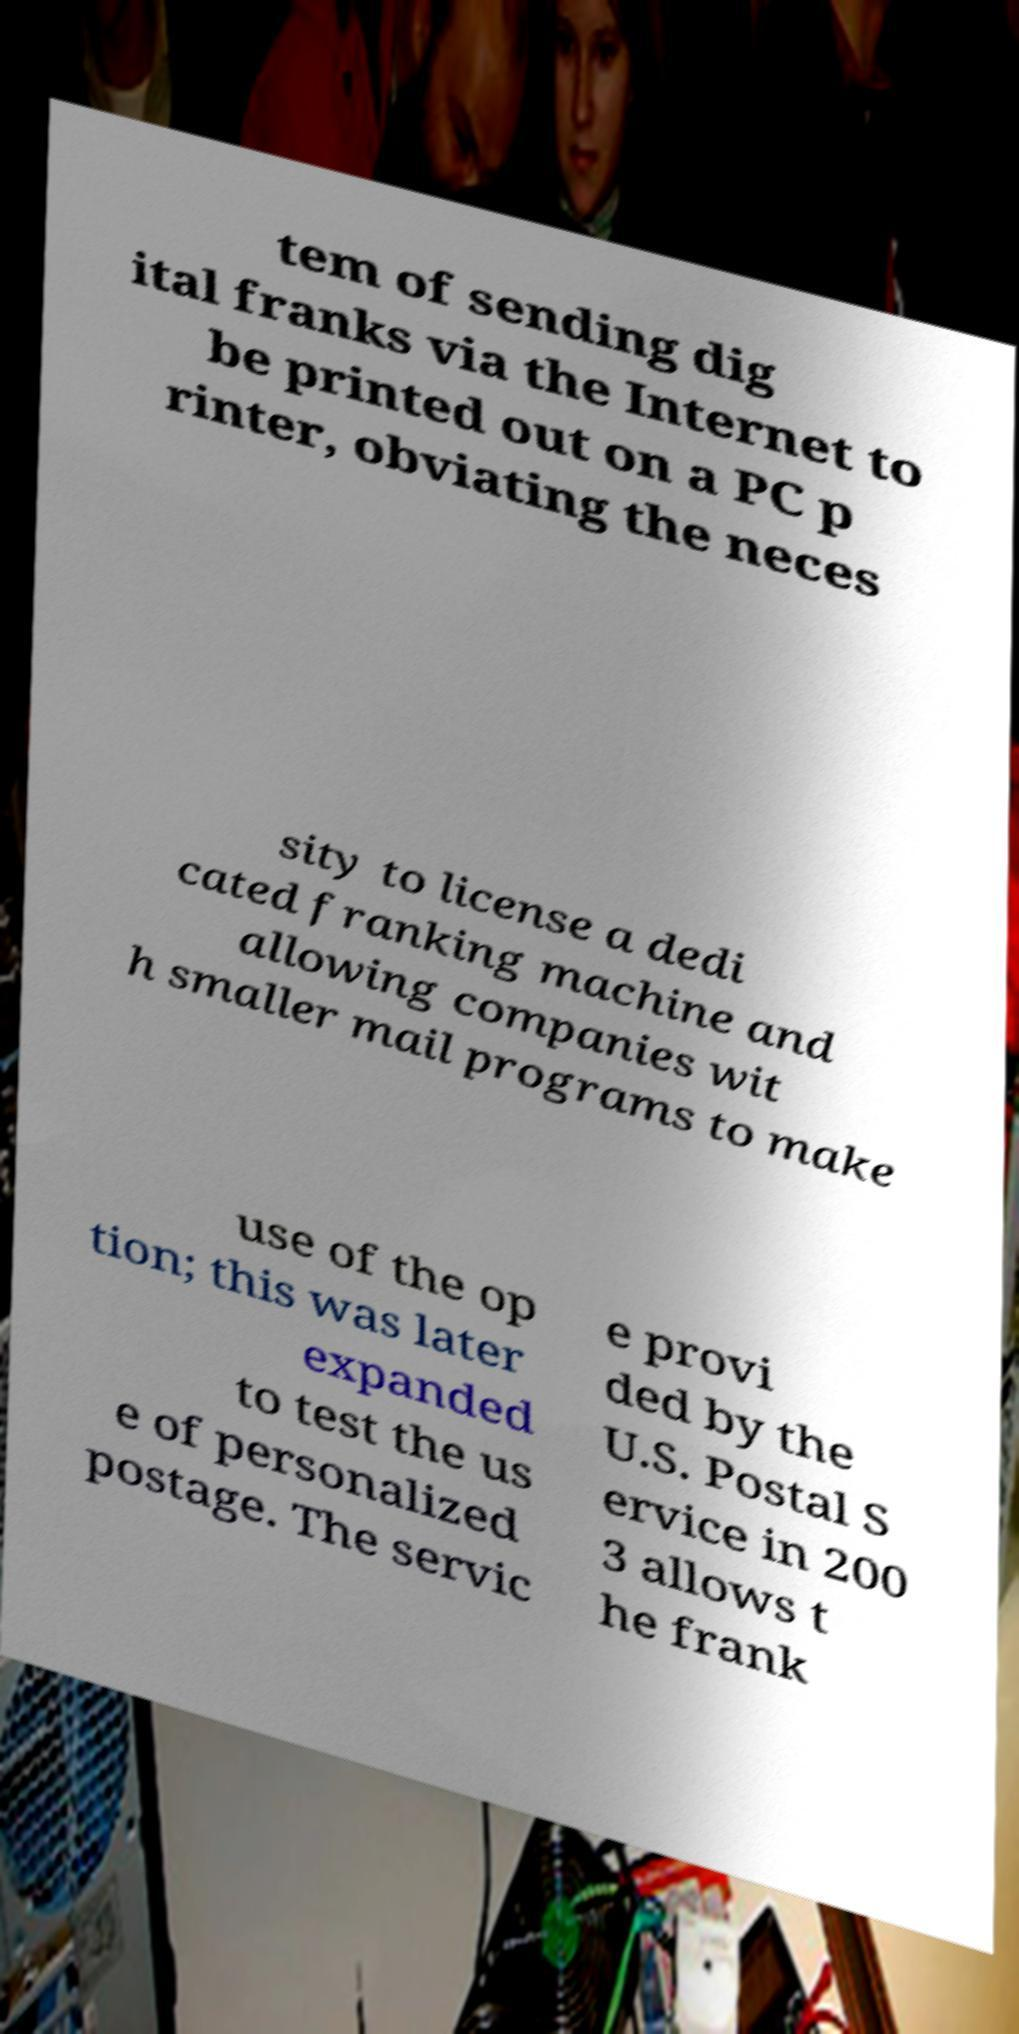Can you read and provide the text displayed in the image?This photo seems to have some interesting text. Can you extract and type it out for me? tem of sending dig ital franks via the Internet to be printed out on a PC p rinter, obviating the neces sity to license a dedi cated franking machine and allowing companies wit h smaller mail programs to make use of the op tion; this was later expanded to test the us e of personalized postage. The servic e provi ded by the U.S. Postal S ervice in 200 3 allows t he frank 